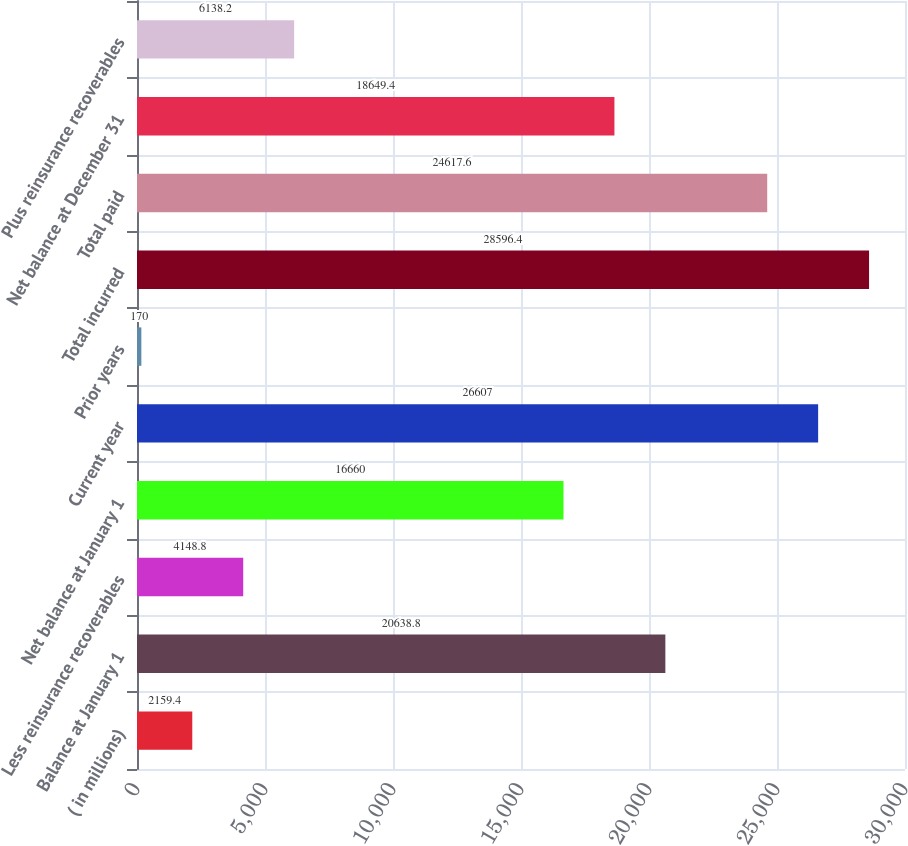Convert chart to OTSL. <chart><loc_0><loc_0><loc_500><loc_500><bar_chart><fcel>( in millions)<fcel>Balance at January 1<fcel>Less reinsurance recoverables<fcel>Net balance at January 1<fcel>Current year<fcel>Prior years<fcel>Total incurred<fcel>Total paid<fcel>Net balance at December 31<fcel>Plus reinsurance recoverables<nl><fcel>2159.4<fcel>20638.8<fcel>4148.8<fcel>16660<fcel>26607<fcel>170<fcel>28596.4<fcel>24617.6<fcel>18649.4<fcel>6138.2<nl></chart> 